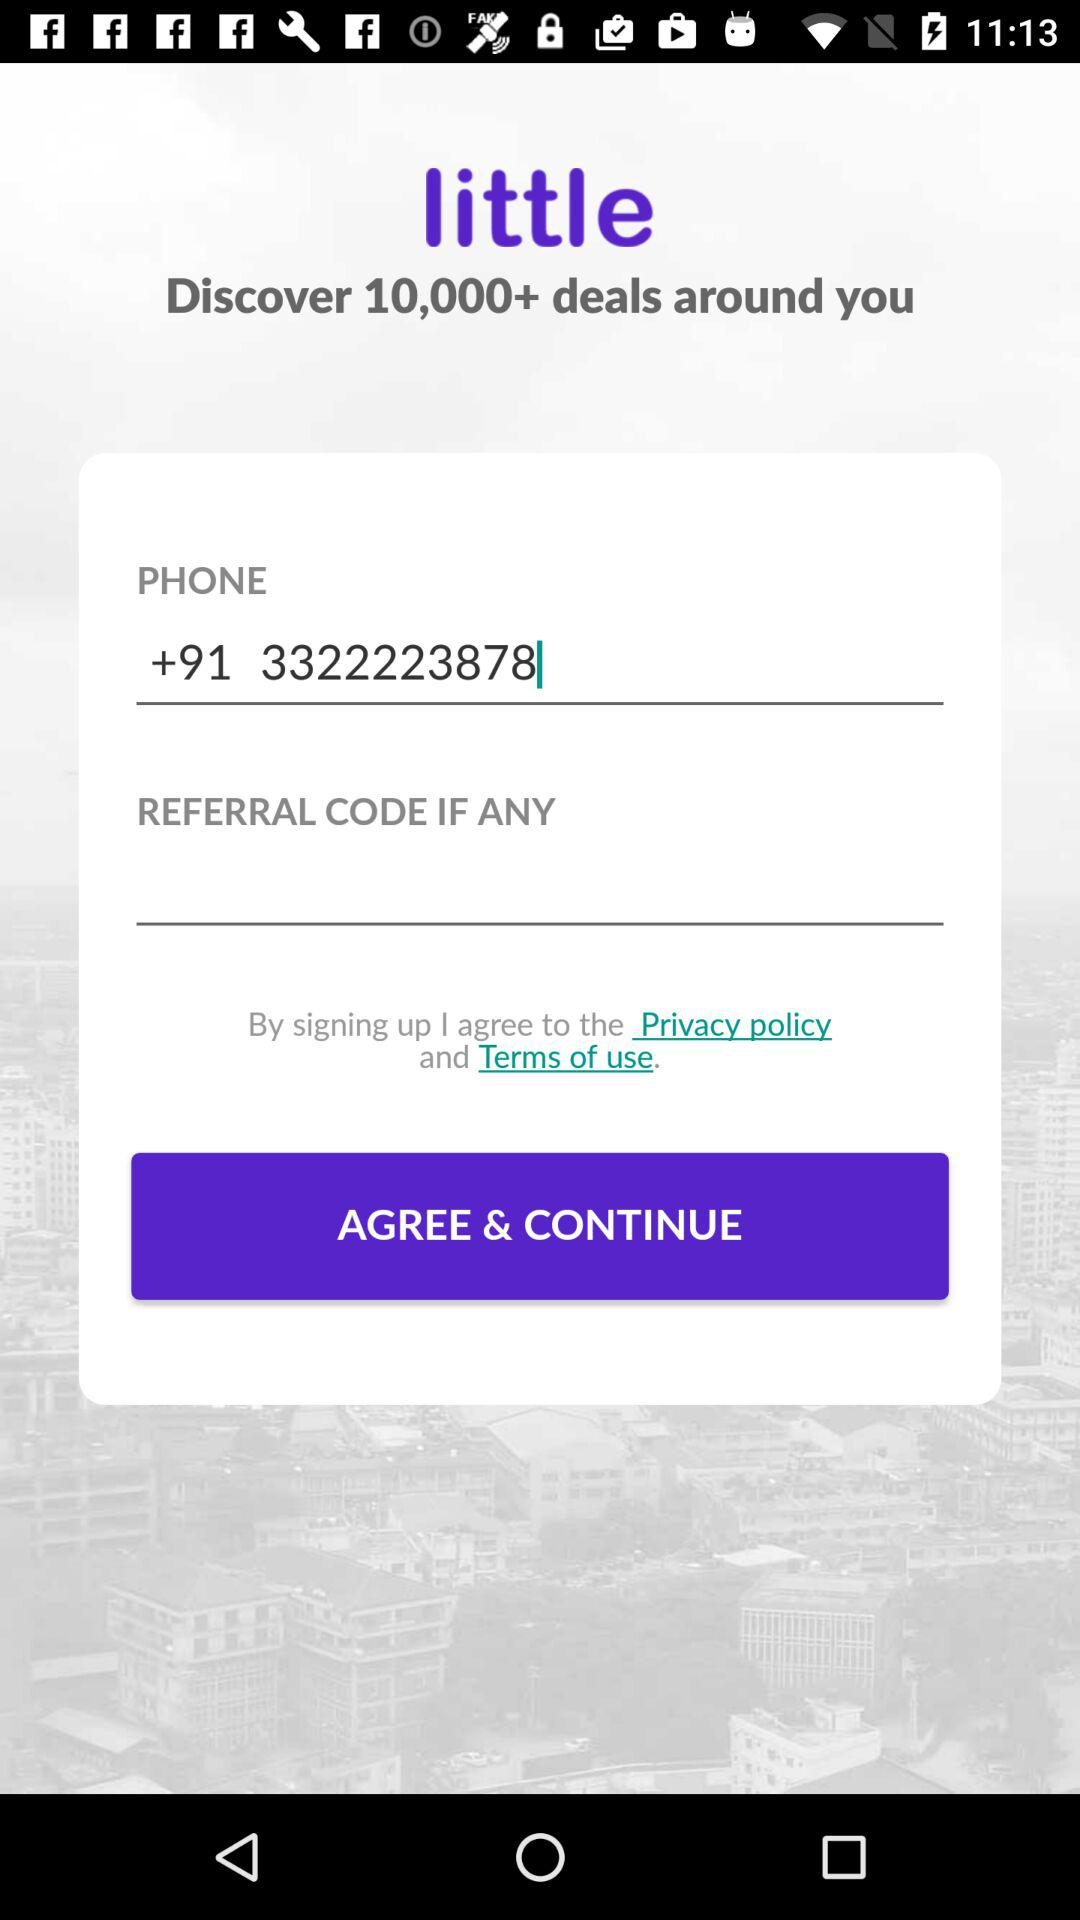How many deals were discovered around me? There were 10,000+ deals discovered around you. 